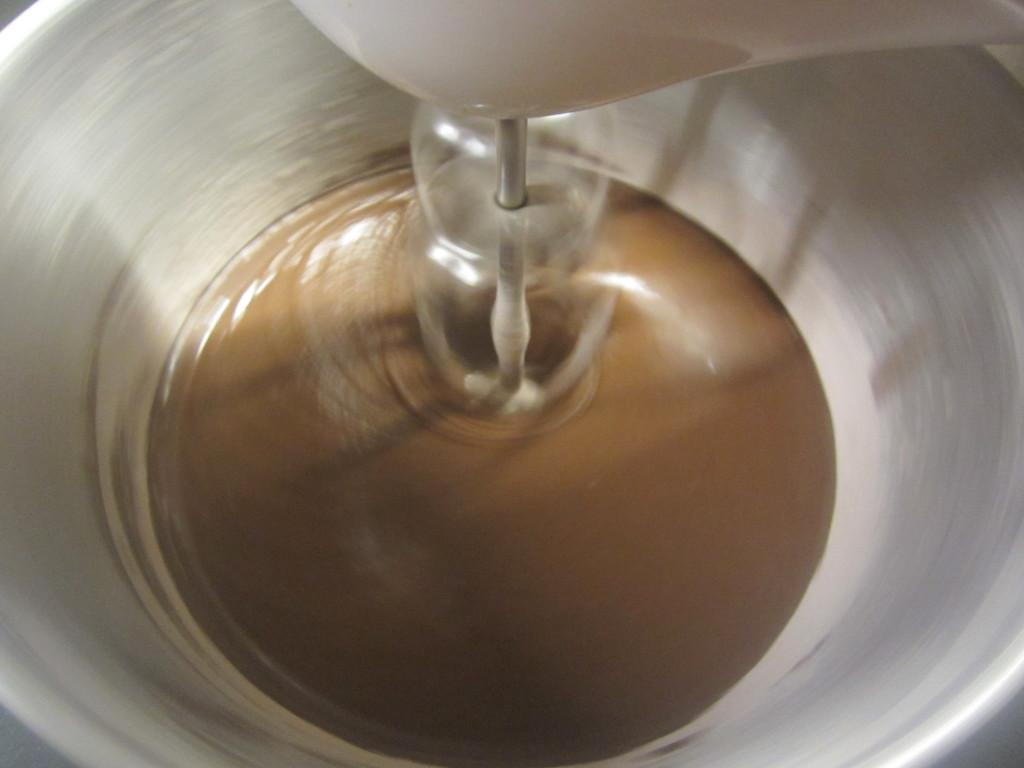How would you summarize this image in a sentence or two? In this image we can see liquid in a bowl and we can see beater. 